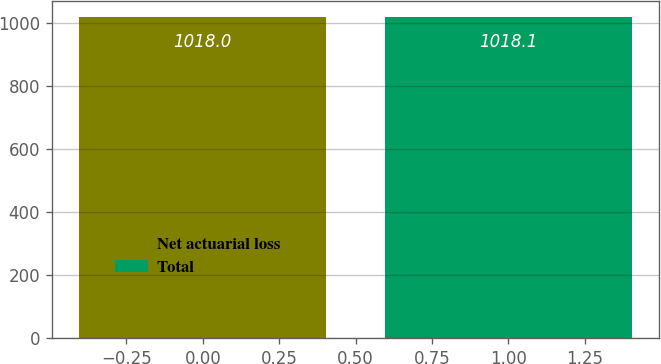Convert chart to OTSL. <chart><loc_0><loc_0><loc_500><loc_500><bar_chart><fcel>Net actuarial loss<fcel>Total<nl><fcel>1018<fcel>1018.1<nl></chart> 